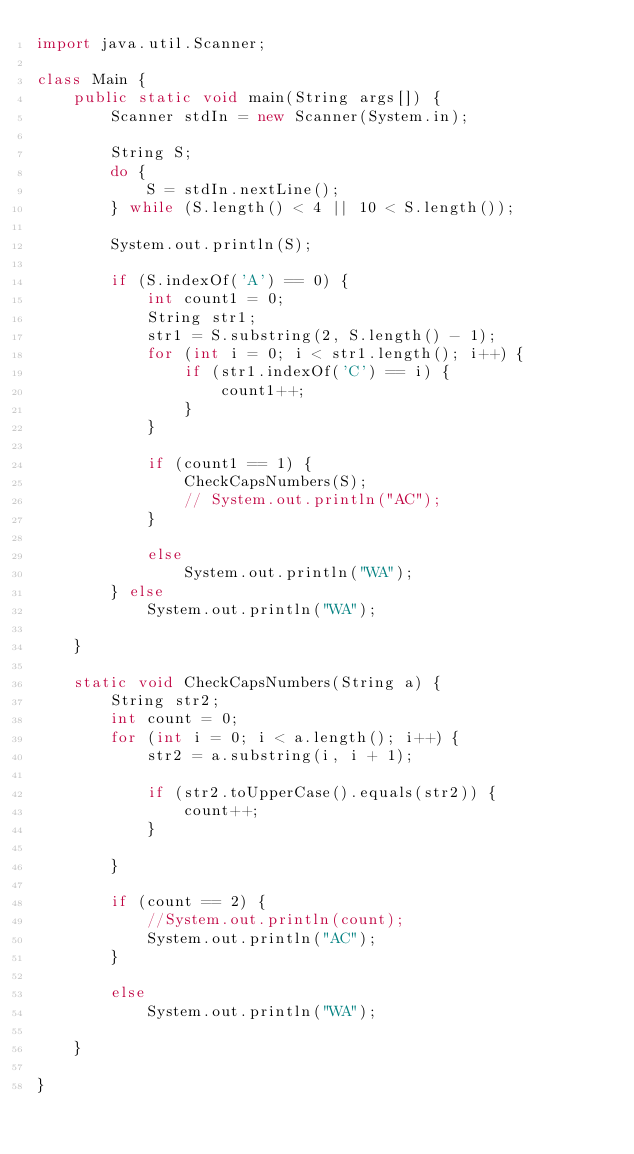<code> <loc_0><loc_0><loc_500><loc_500><_Java_>import java.util.Scanner;

class Main {
    public static void main(String args[]) {
        Scanner stdIn = new Scanner(System.in);

        String S;
        do {
            S = stdIn.nextLine();
        } while (S.length() < 4 || 10 < S.length());

        System.out.println(S);

        if (S.indexOf('A') == 0) {
            int count1 = 0;
            String str1;
            str1 = S.substring(2, S.length() - 1);
            for (int i = 0; i < str1.length(); i++) {
                if (str1.indexOf('C') == i) {
                    count1++;
                }
            }

            if (count1 == 1) {
                CheckCapsNumbers(S);
                // System.out.println("AC");
            }

            else
                System.out.println("WA");
        } else
            System.out.println("WA");

    }

    static void CheckCapsNumbers(String a) {
        String str2;
        int count = 0;
        for (int i = 0; i < a.length(); i++) {
            str2 = a.substring(i, i + 1);

            if (str2.toUpperCase().equals(str2)) {
                count++;
            }

        }

        if (count == 2) {
            //System.out.println(count);
            System.out.println("AC");
        }

        else
            System.out.println("WA");

    }

}
</code> 